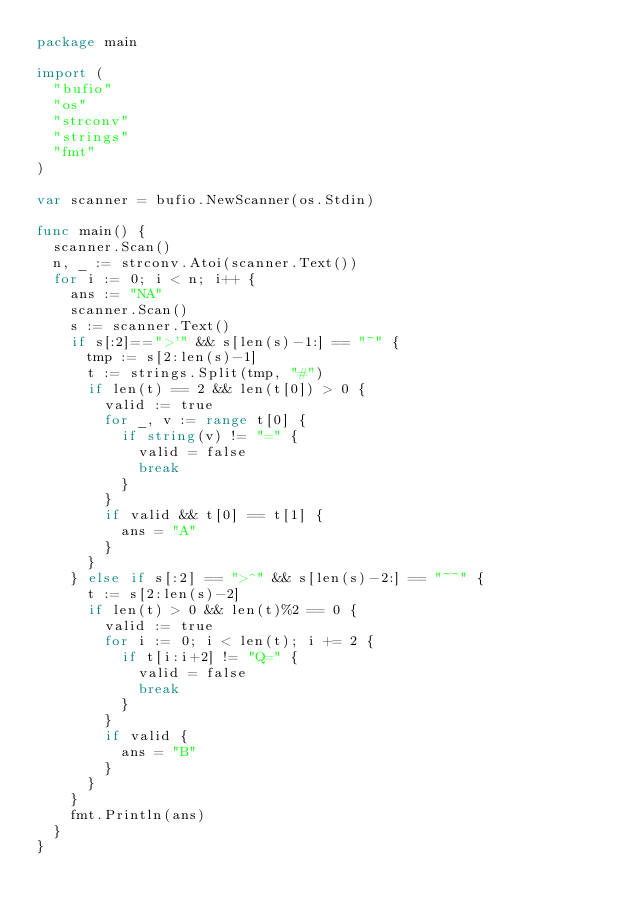<code> <loc_0><loc_0><loc_500><loc_500><_Go_>package main

import (
	"bufio"
	"os"
	"strconv"
	"strings"
	"fmt"
)

var scanner = bufio.NewScanner(os.Stdin)

func main() {
	scanner.Scan()
	n, _ := strconv.Atoi(scanner.Text())
	for i := 0; i < n; i++ {
		ans := "NA"
		scanner.Scan()
		s := scanner.Text()
		if s[:2]==">'" && s[len(s)-1:] == "~" {
			tmp := s[2:len(s)-1]
			t := strings.Split(tmp, "#")
			if len(t) == 2 && len(t[0]) > 0 {
				valid := true
				for _, v := range t[0] {
					if string(v) != "=" {
						valid = false
						break
					}
				}
				if valid && t[0] == t[1] {
					ans = "A"
				}
			}
		} else if s[:2] == ">^" && s[len(s)-2:] == "~~" {
			t := s[2:len(s)-2]
			if len(t) > 0 && len(t)%2 == 0 {
				valid := true
				for i := 0; i < len(t); i += 2 {
					if t[i:i+2] != "Q=" {
						valid = false
						break
					}
				}
				if valid {
					ans = "B"
				}
			}
 		}
		fmt.Println(ans)
	}
}
</code> 